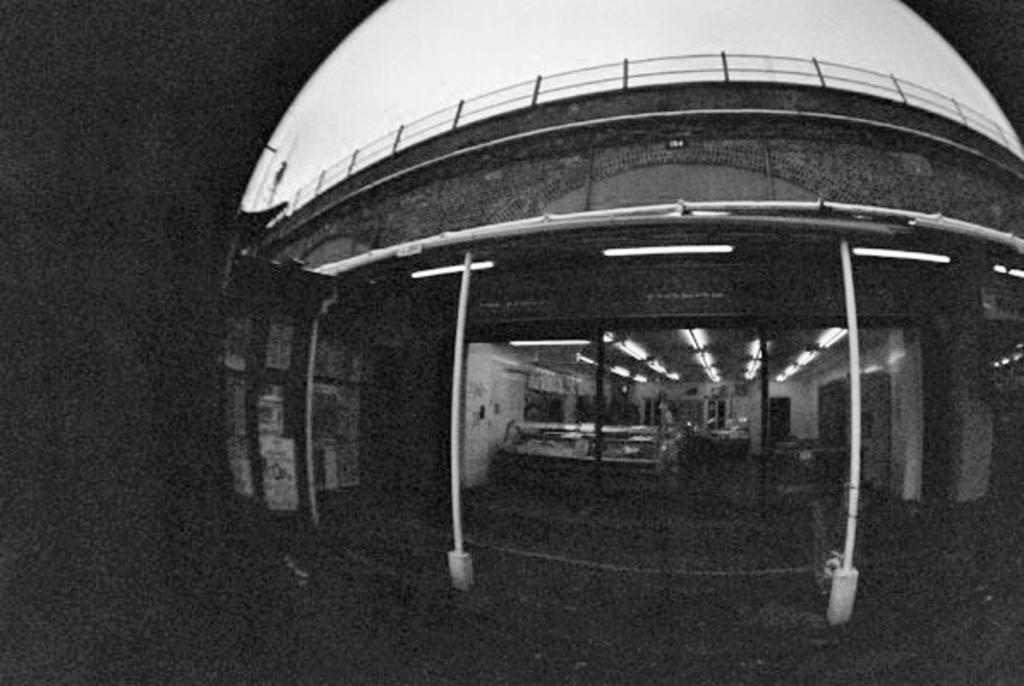What type of structure is present in the image? There is a building in the image. What is the color scheme of the image? The image is in black and white. Can you see a stranger flying a kite made of lettuce in the image? No, there is no stranger, kite, or lettuce present in the image. 